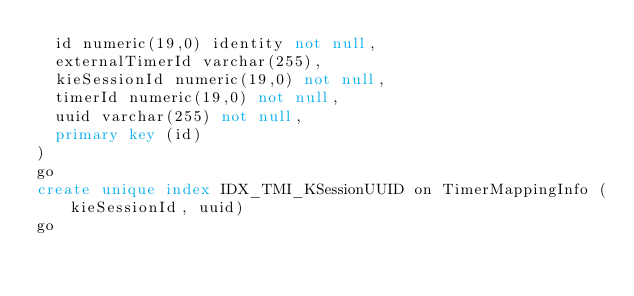Convert code to text. <code><loc_0><loc_0><loc_500><loc_500><_SQL_>	id numeric(19,0) identity not null, 
	externalTimerId varchar(255), 
	kieSessionId numeric(19,0) not null, 
	timerId numeric(19,0) not null, 
	uuid varchar(255) not null, 
	primary key (id)
)
go
create unique index IDX_TMI_KSessionUUID on TimerMappingInfo (kieSessionId, uuid)
go
</code> 